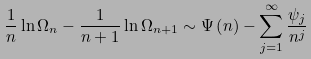Convert formula to latex. <formula><loc_0><loc_0><loc_500><loc_500>\frac { 1 } { n } \ln \Omega _ { n } - \frac { 1 } { n + 1 } \ln \Omega _ { n + 1 } \sim \Psi \left ( n \right ) - \sum _ { j = 1 } ^ { \infty } \frac { \psi _ { j } } { n ^ { j } }</formula> 